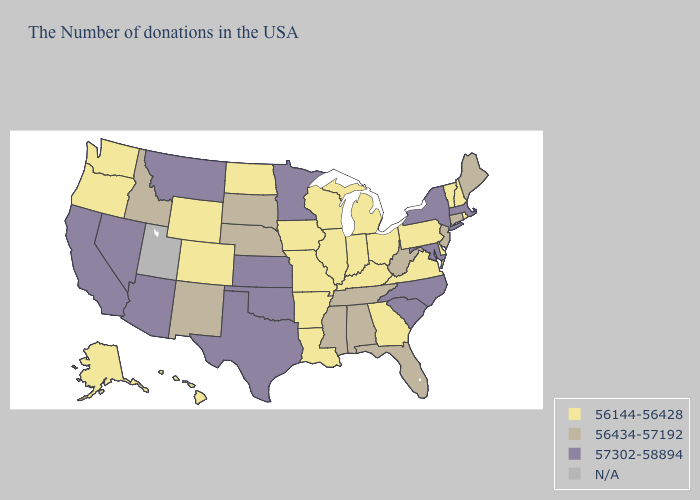What is the lowest value in the West?
Give a very brief answer. 56144-56428. Does Wyoming have the lowest value in the USA?
Concise answer only. Yes. Among the states that border Maine , which have the highest value?
Short answer required. New Hampshire. Does New Mexico have the lowest value in the USA?
Quick response, please. No. Among the states that border West Virginia , does Ohio have the highest value?
Answer briefly. No. What is the value of Kentucky?
Give a very brief answer. 56144-56428. Which states have the lowest value in the MidWest?
Concise answer only. Ohio, Michigan, Indiana, Wisconsin, Illinois, Missouri, Iowa, North Dakota. Name the states that have a value in the range N/A?
Be succinct. Utah. Is the legend a continuous bar?
Answer briefly. No. Does Nebraska have the highest value in the USA?
Write a very short answer. No. Name the states that have a value in the range 57302-58894?
Answer briefly. Massachusetts, New York, Maryland, North Carolina, South Carolina, Minnesota, Kansas, Oklahoma, Texas, Montana, Arizona, Nevada, California. Among the states that border Delaware , does Maryland have the highest value?
Concise answer only. Yes. What is the value of Michigan?
Be succinct. 56144-56428. Is the legend a continuous bar?
Quick response, please. No. Among the states that border South Dakota , does Iowa have the highest value?
Concise answer only. No. 